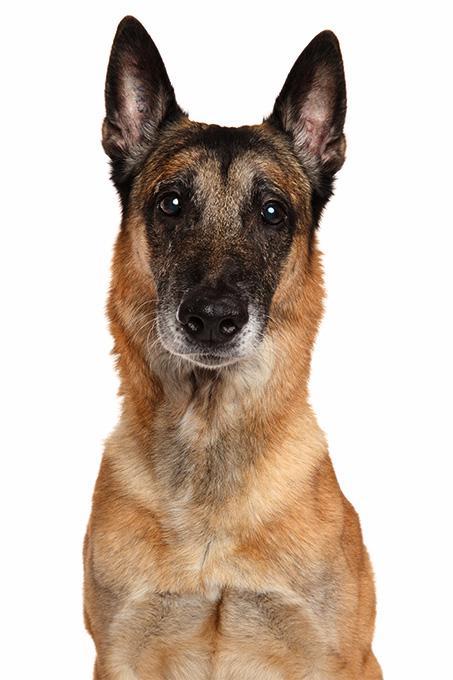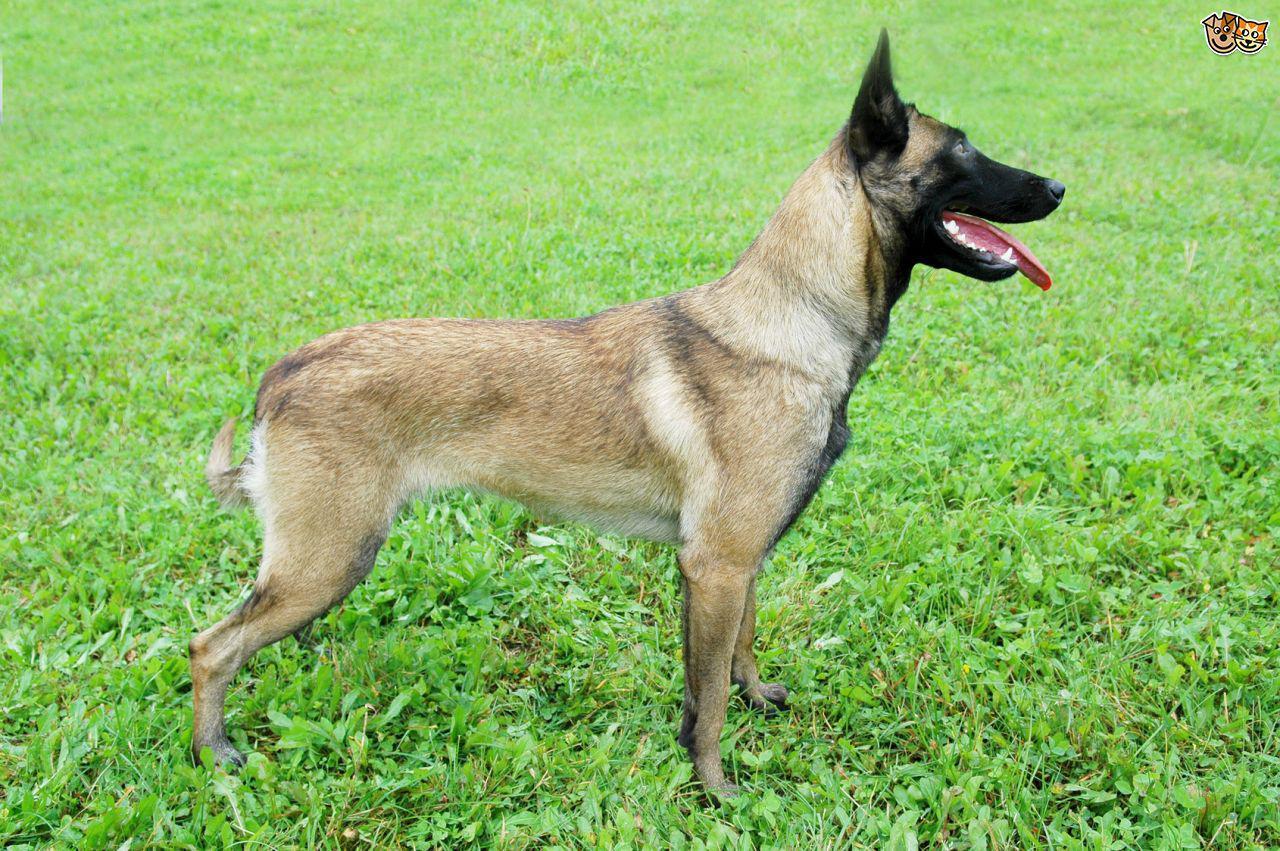The first image is the image on the left, the second image is the image on the right. Analyze the images presented: Is the assertion "A dog is moving rightward across the grass, with at least two paws off the ground." valid? Answer yes or no. No. The first image is the image on the left, the second image is the image on the right. Examine the images to the left and right. Is the description "In one of the images, a dog can be seen running in a green grassy area facing rightward." accurate? Answer yes or no. No. 